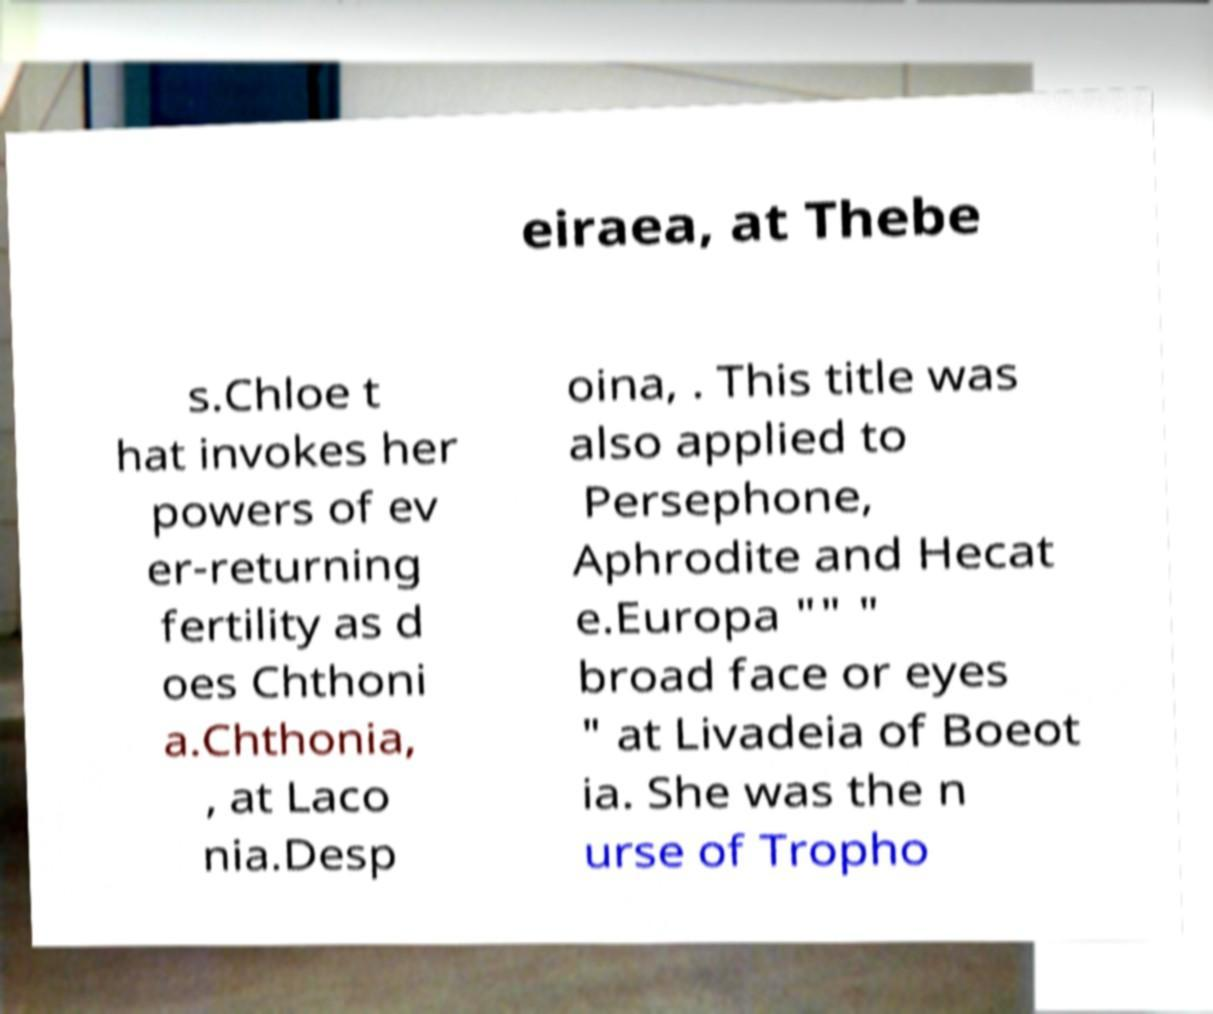Can you read and provide the text displayed in the image?This photo seems to have some interesting text. Can you extract and type it out for me? eiraea, at Thebe s.Chloe t hat invokes her powers of ev er-returning fertility as d oes Chthoni a.Chthonia, , at Laco nia.Desp oina, . This title was also applied to Persephone, Aphrodite and Hecat e.Europa "" " broad face or eyes " at Livadeia of Boeot ia. She was the n urse of Tropho 